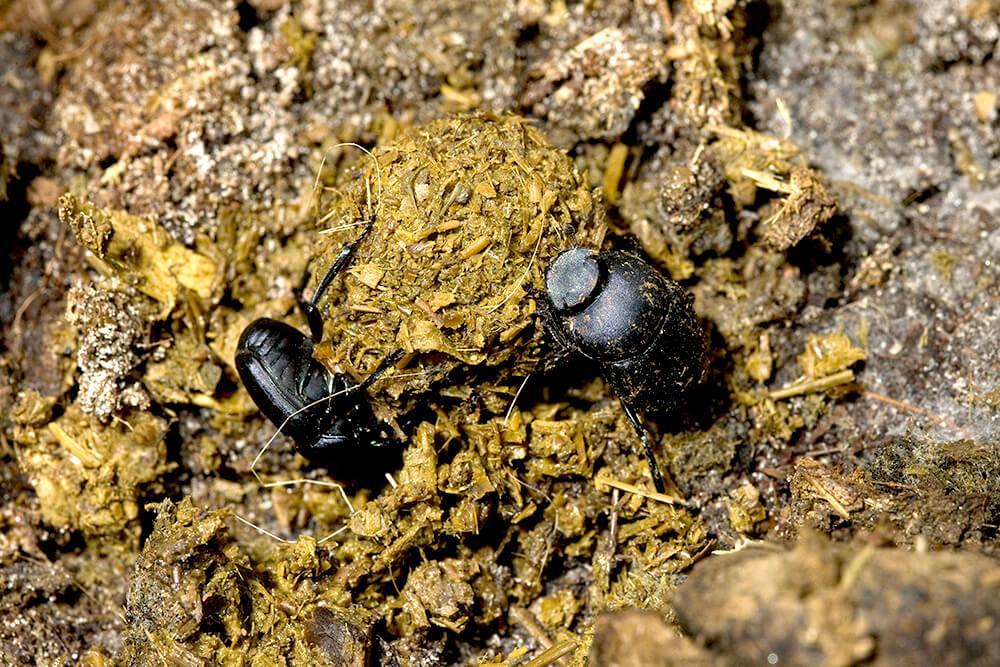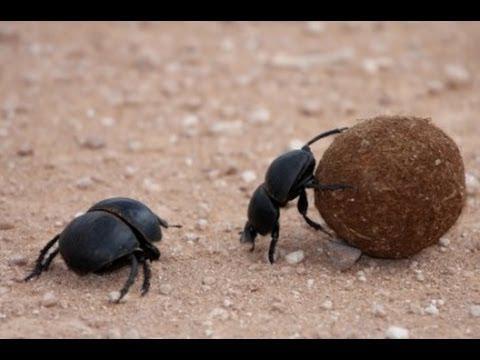The first image is the image on the left, the second image is the image on the right. Considering the images on both sides, is "Each image shows just one beetle in contact with one round dung ball." valid? Answer yes or no. No. 